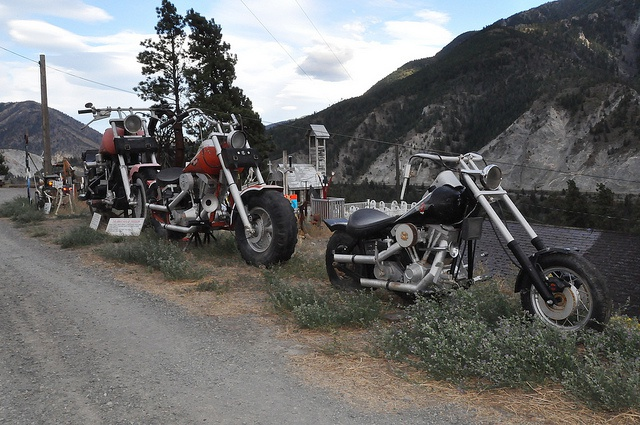Describe the objects in this image and their specific colors. I can see motorcycle in lavender, black, gray, darkgray, and lightgray tones, motorcycle in lavender, black, gray, darkgray, and maroon tones, and motorcycle in lavender, black, gray, darkgray, and lightgray tones in this image. 